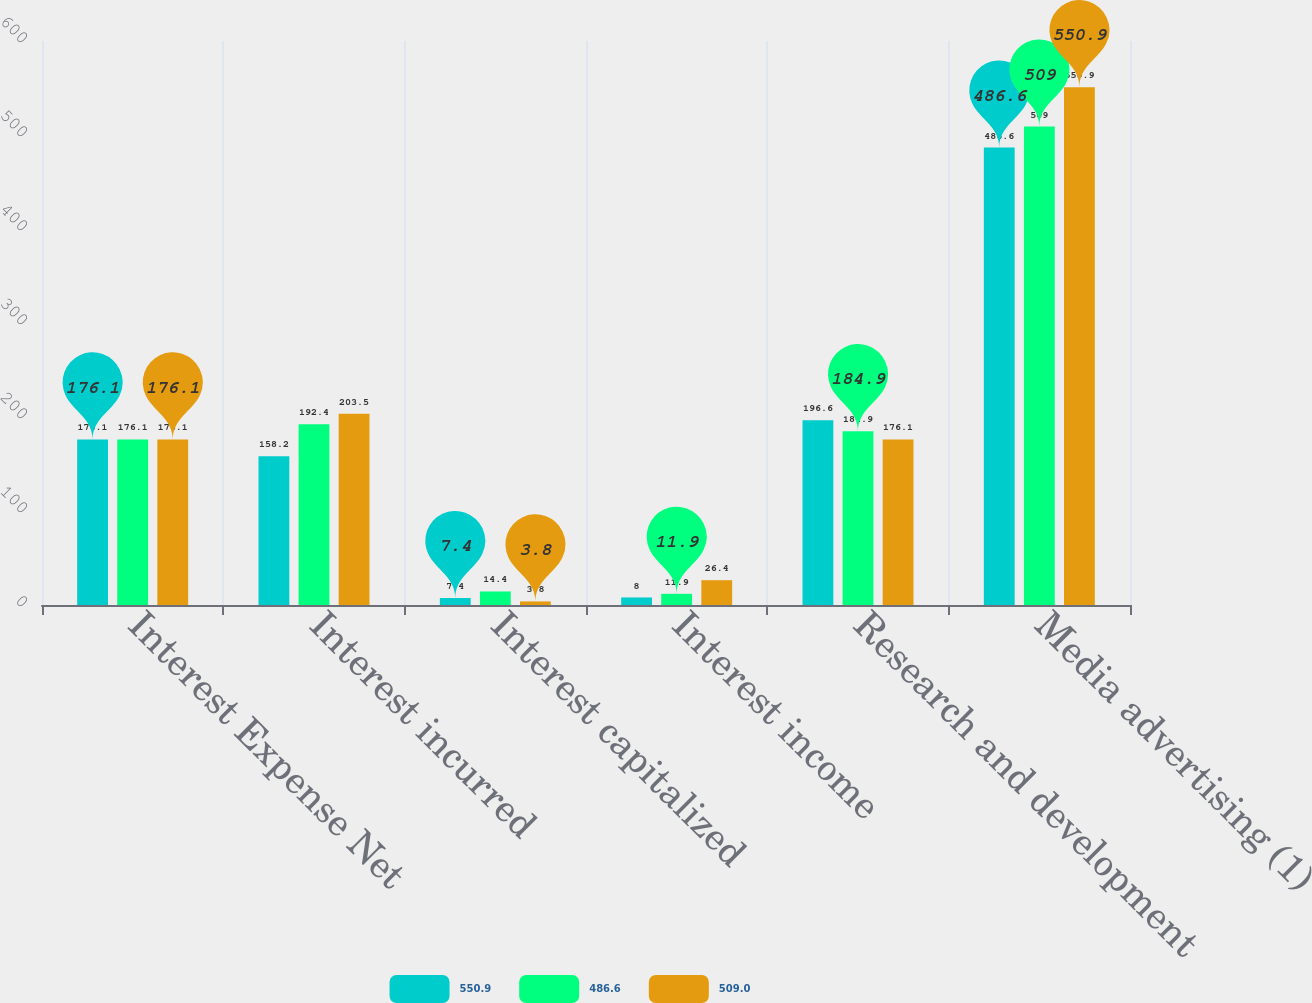Convert chart to OTSL. <chart><loc_0><loc_0><loc_500><loc_500><stacked_bar_chart><ecel><fcel>Interest Expense Net<fcel>Interest incurred<fcel>Interest capitalized<fcel>Interest income<fcel>Research and development<fcel>Media advertising (1)<nl><fcel>550.9<fcel>176.1<fcel>158.2<fcel>7.4<fcel>8<fcel>196.6<fcel>486.6<nl><fcel>486.6<fcel>176.1<fcel>192.4<fcel>14.4<fcel>11.9<fcel>184.9<fcel>509<nl><fcel>509<fcel>176.1<fcel>203.5<fcel>3.8<fcel>26.4<fcel>176.1<fcel>550.9<nl></chart> 